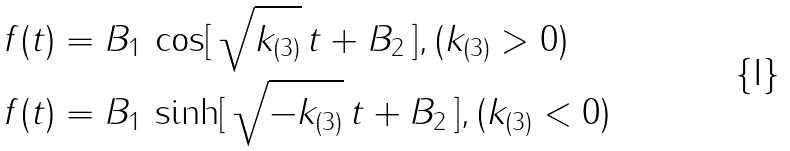<formula> <loc_0><loc_0><loc_500><loc_500>& f ( t ) = B _ { 1 } \, \cos [ \, \sqrt { k _ { ( 3 ) } } \, t + B _ { 2 } \, ] , ( k _ { ( 3 ) } > 0 ) \\ & f ( t ) = B _ { 1 } \, \sinh [ \, \sqrt { - k _ { ( 3 ) } } \, t + B _ { 2 } \, ] , ( k _ { ( 3 ) } < 0 )</formula> 